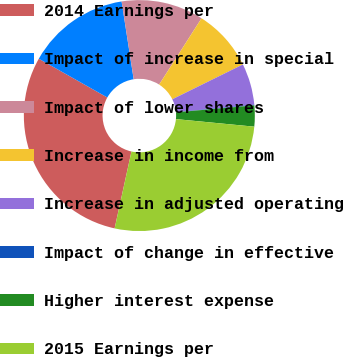Convert chart to OTSL. <chart><loc_0><loc_0><loc_500><loc_500><pie_chart><fcel>2014 Earnings per<fcel>Impact of increase in special<fcel>Impact of lower shares<fcel>Increase in income from<fcel>Increase in adjusted operating<fcel>Impact of change in effective<fcel>Higher interest expense<fcel>2015 Earnings per<nl><fcel>29.76%<fcel>14.36%<fcel>11.51%<fcel>8.65%<fcel>5.8%<fcel>0.09%<fcel>2.94%<fcel>26.9%<nl></chart> 